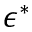<formula> <loc_0><loc_0><loc_500><loc_500>\epsilon ^ { * }</formula> 